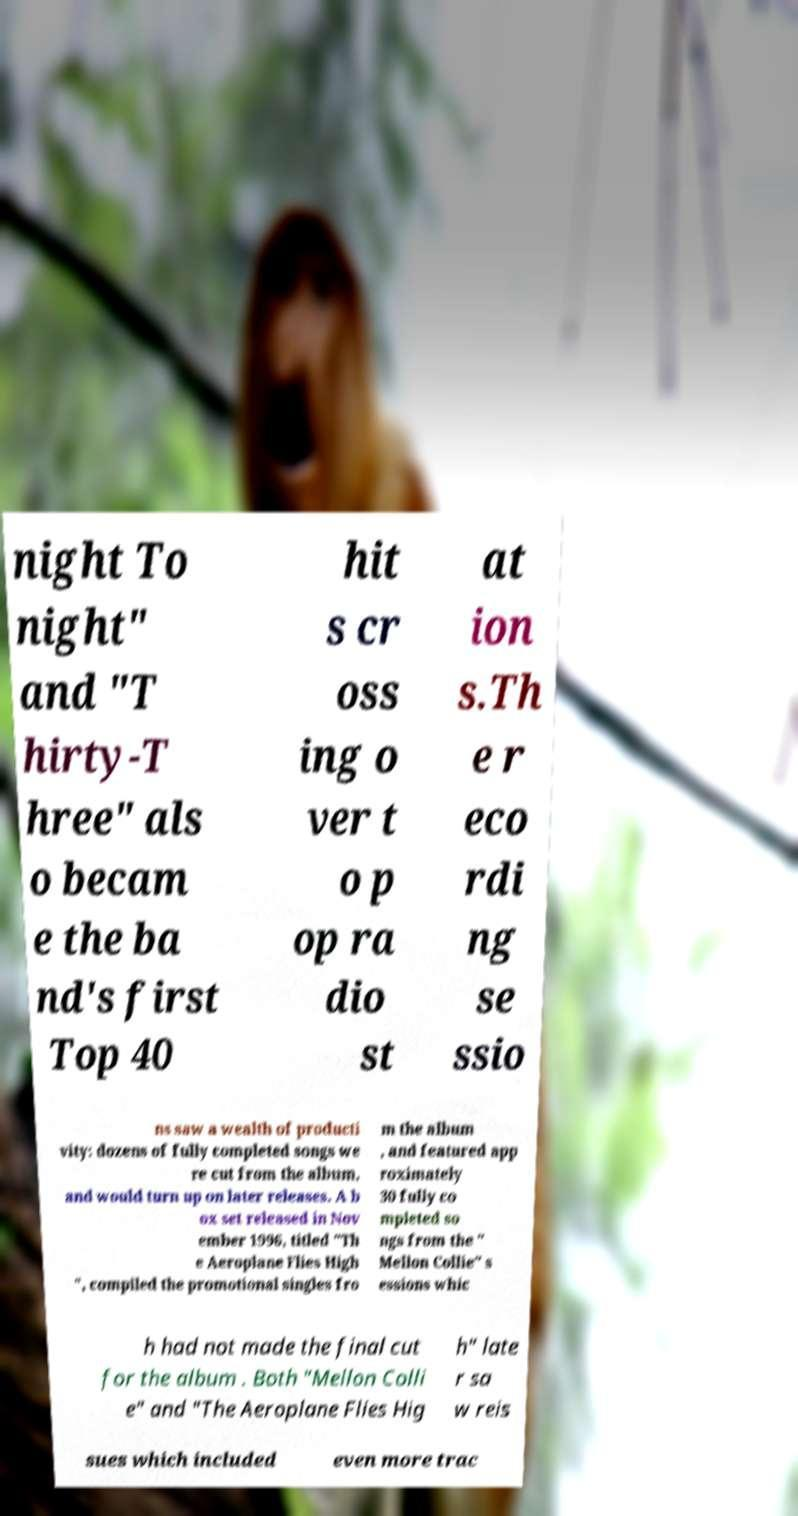Can you accurately transcribe the text from the provided image for me? night To night" and "T hirty-T hree" als o becam e the ba nd's first Top 40 hit s cr oss ing o ver t o p op ra dio st at ion s.Th e r eco rdi ng se ssio ns saw a wealth of producti vity: dozens of fully completed songs we re cut from the album, and would turn up on later releases. A b ox set released in Nov ember 1996, titled "Th e Aeroplane Flies High ", compiled the promotional singles fro m the album , and featured app roximately 30 fully co mpleted so ngs from the " Mellon Collie" s essions whic h had not made the final cut for the album . Both "Mellon Colli e" and "The Aeroplane Flies Hig h" late r sa w reis sues which included even more trac 